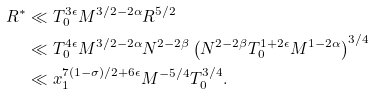Convert formula to latex. <formula><loc_0><loc_0><loc_500><loc_500>R ^ { * } & \ll T _ { 0 } ^ { 3 \epsilon } M ^ { 3 / 2 - 2 \alpha } R ^ { 5 / 2 } \\ & \ll T _ { 0 } ^ { 4 \epsilon } M ^ { 3 / 2 - 2 \alpha } N ^ { 2 - 2 \beta } \left ( N ^ { 2 - 2 \beta } T _ { 0 } ^ { 1 + 2 \epsilon } M ^ { 1 - 2 \alpha } \right ) ^ { 3 / 4 } \\ & \ll x _ { 1 } ^ { 7 ( 1 - \sigma ) / 2 + 6 \epsilon } M ^ { - 5 / 4 } T _ { 0 } ^ { 3 / 4 } .</formula> 